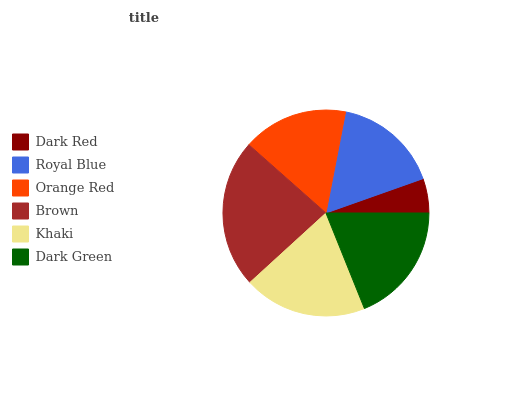Is Dark Red the minimum?
Answer yes or no. Yes. Is Brown the maximum?
Answer yes or no. Yes. Is Royal Blue the minimum?
Answer yes or no. No. Is Royal Blue the maximum?
Answer yes or no. No. Is Royal Blue greater than Dark Red?
Answer yes or no. Yes. Is Dark Red less than Royal Blue?
Answer yes or no. Yes. Is Dark Red greater than Royal Blue?
Answer yes or no. No. Is Royal Blue less than Dark Red?
Answer yes or no. No. Is Dark Green the high median?
Answer yes or no. Yes. Is Royal Blue the low median?
Answer yes or no. Yes. Is Orange Red the high median?
Answer yes or no. No. Is Dark Green the low median?
Answer yes or no. No. 